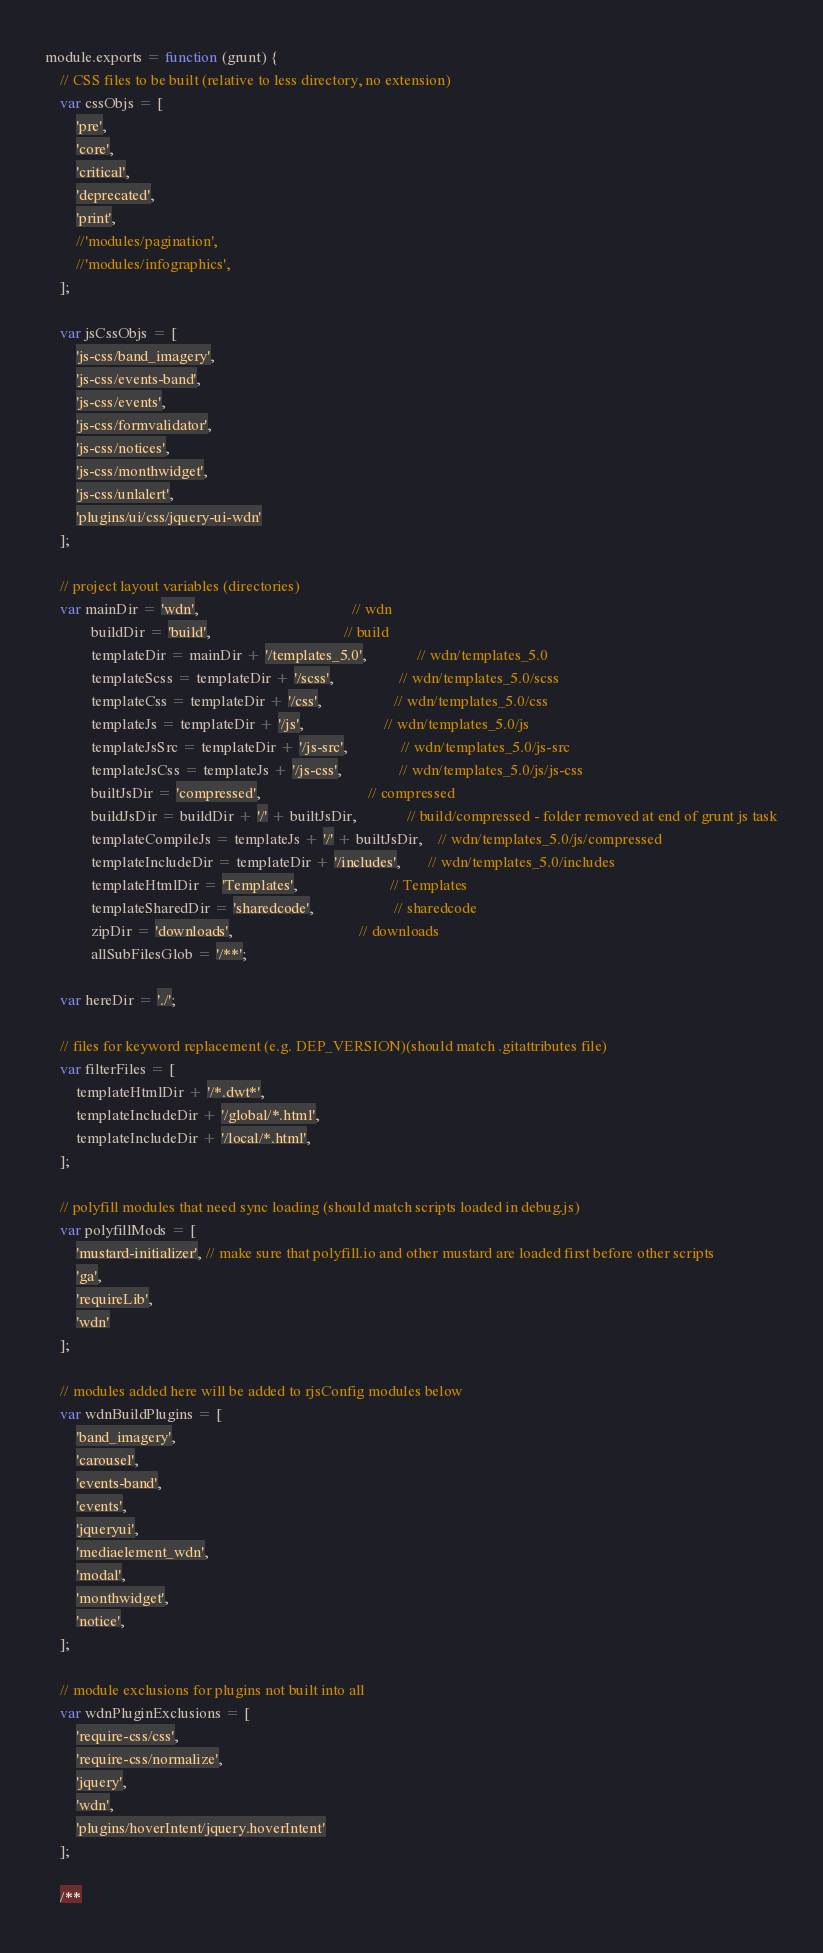<code> <loc_0><loc_0><loc_500><loc_500><_JavaScript_>module.exports = function (grunt) {
	// CSS files to be built (relative to less directory, no extension)
	var cssObjs = [
		'pre',
		'core',
		'critical',
		'deprecated',
		'print',
		//'modules/pagination',
		//'modules/infographics',
	];

	var jsCssObjs = [
		'js-css/band_imagery',
		'js-css/events-band',
		'js-css/events',
		'js-css/formvalidator',
		'js-css/notices',
		'js-css/monthwidget',
		'js-css/unlalert',
		'plugins/ui/css/jquery-ui-wdn'
	];

	// project layout variables (directories)
	var mainDir = 'wdn',                                    	// wdn
			buildDir = 'build',                                   // build
			templateDir = mainDir + '/templates_5.0',             // wdn/templates_5.0
			templateScss = templateDir + '/scss',                 // wdn/templates_5.0/scss
			templateCss = templateDir + '/css',                   // wdn/templates_5.0/css
			templateJs = templateDir + '/js',                     // wdn/templates_5.0/js
			templateJsSrc = templateDir + '/js-src',              // wdn/templates_5.0/js-src
			templateJsCss = templateJs + '/js-css',               // wdn/templates_5.0/js/js-css
			builtJsDir = 'compressed',                            // compressed
			buildJsDir = buildDir + '/' + builtJsDir,             // build/compressed - folder removed at end of grunt js task
			templateCompileJs = templateJs + '/' + builtJsDir,    // wdn/templates_5.0/js/compressed
			templateIncludeDir = templateDir + '/includes',       // wdn/templates_5.0/includes
			templateHtmlDir = 'Templates',                        // Templates
			templateSharedDir = 'sharedcode',                     // sharedcode
			zipDir = 'downloads',                                 // downloads
			allSubFilesGlob = '/**';

	var hereDir = './';

	// files for keyword replacement (e.g. DEP_VERSION)(should match .gitattributes file)
	var filterFiles = [
		templateHtmlDir + '/*.dwt*',
		templateIncludeDir + '/global/*.html',
		templateIncludeDir + '/local/*.html',
	];

	// polyfill modules that need sync loading (should match scripts loaded in debug.js)
	var polyfillMods = [
		'mustard-initializer', // make sure that polyfill.io and other mustard are loaded first before other scripts
		'ga',
		'requireLib',
		'wdn'
	];

	// modules added here will be added to rjsConfig modules below
	var wdnBuildPlugins = [
		'band_imagery',
		'carousel',
		'events-band',
		'events',
		'jqueryui',
		'mediaelement_wdn',
		'modal',
		'monthwidget',
		'notice',
	];

	// module exclusions for plugins not built into all
	var wdnPluginExclusions = [
		'require-css/css',
		'require-css/normalize',
		'jquery',
		'wdn',
		'plugins/hoverIntent/jquery.hoverIntent'
	];

	/**</code> 